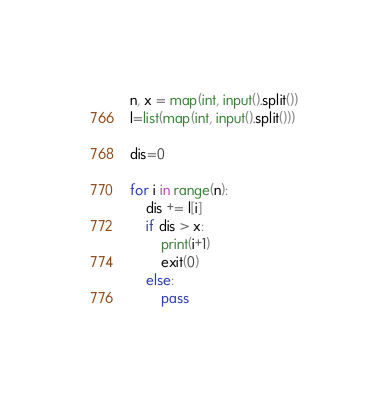Convert code to text. <code><loc_0><loc_0><loc_500><loc_500><_Python_>n, x = map(int, input().split())
l=list(map(int, input().split()))

dis=0

for i in range(n):
    dis += l[i]
    if dis > x:
        print(i+1)
        exit(0)
    else:
        pass</code> 